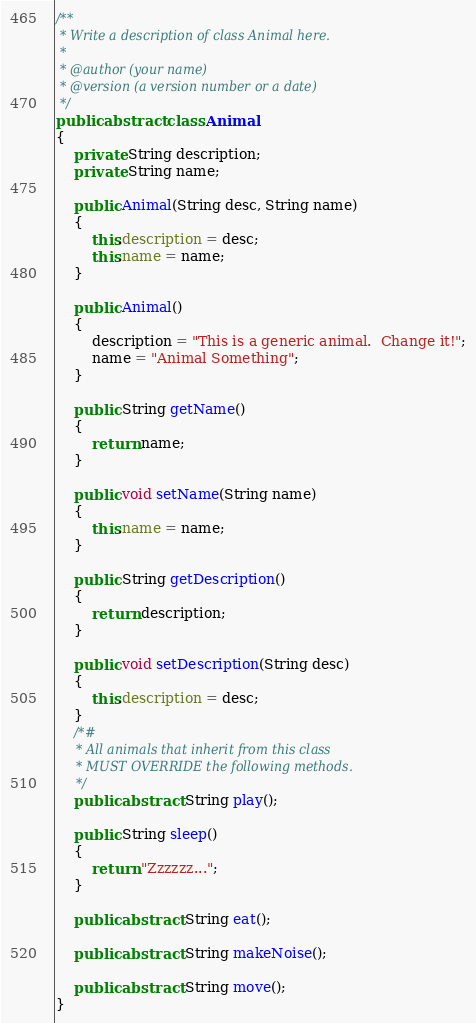Convert code to text. <code><loc_0><loc_0><loc_500><loc_500><_Java_>
/**
 * Write a description of class Animal here.
 * 
 * @author (your name) 
 * @version (a version number or a date)
 */
public abstract class Animal
{
    private String description;
    private String name;

    public Animal(String desc, String name)
    {
        this.description = desc;
        this.name = name;
    }

    public Animal()
    {
        description = "This is a generic animal.  Change it!";
        name = "Animal Something";
    }

    public String getName()
    {
        return name;
    }
    
    public void setName(String name)
    {
        this.name = name;
    }
    
    public String getDescription()
    {
        return description;
    }
    
    public void setDescription(String desc)
    {
        this.description = desc;
    }
    /*#
     * All animals that inherit from this class
     * MUST OVERRIDE the following methods.
     */
    public abstract String play();

    public String sleep()
    {
        return "Zzzzzz...";
    }

    public abstract String eat();

    public abstract String makeNoise();

    public abstract String move();
}
</code> 